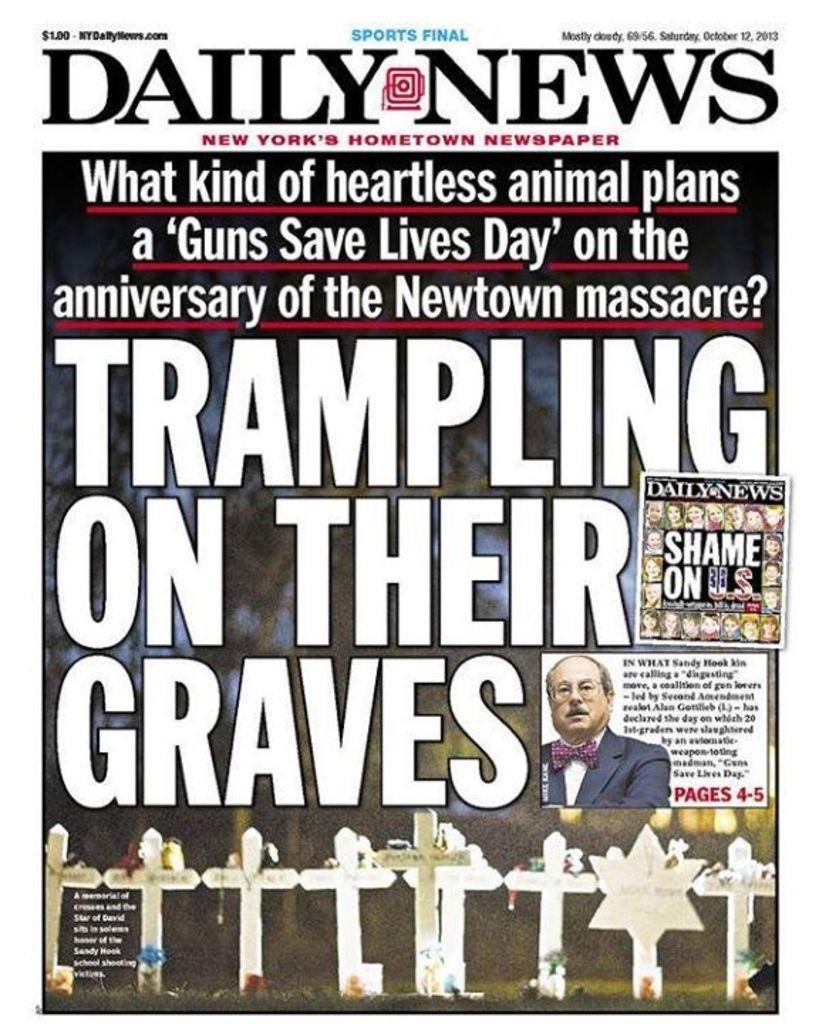What religious symbols can be seen in the image? There are religious cross symbols in the image. Can you describe the person in the image? There is a person in the image. What is written on the image? There is text written on the image. What colors make up the background of the image? The background color consists of blue and green. What type of spacecraft can be seen in the image? There is no spacecraft present in the image; it features religious cross symbols, a person, text, and a blue-green background. Can you tell me how many cows are on the farm in the image? There is no farm or cows depicted in the image. 